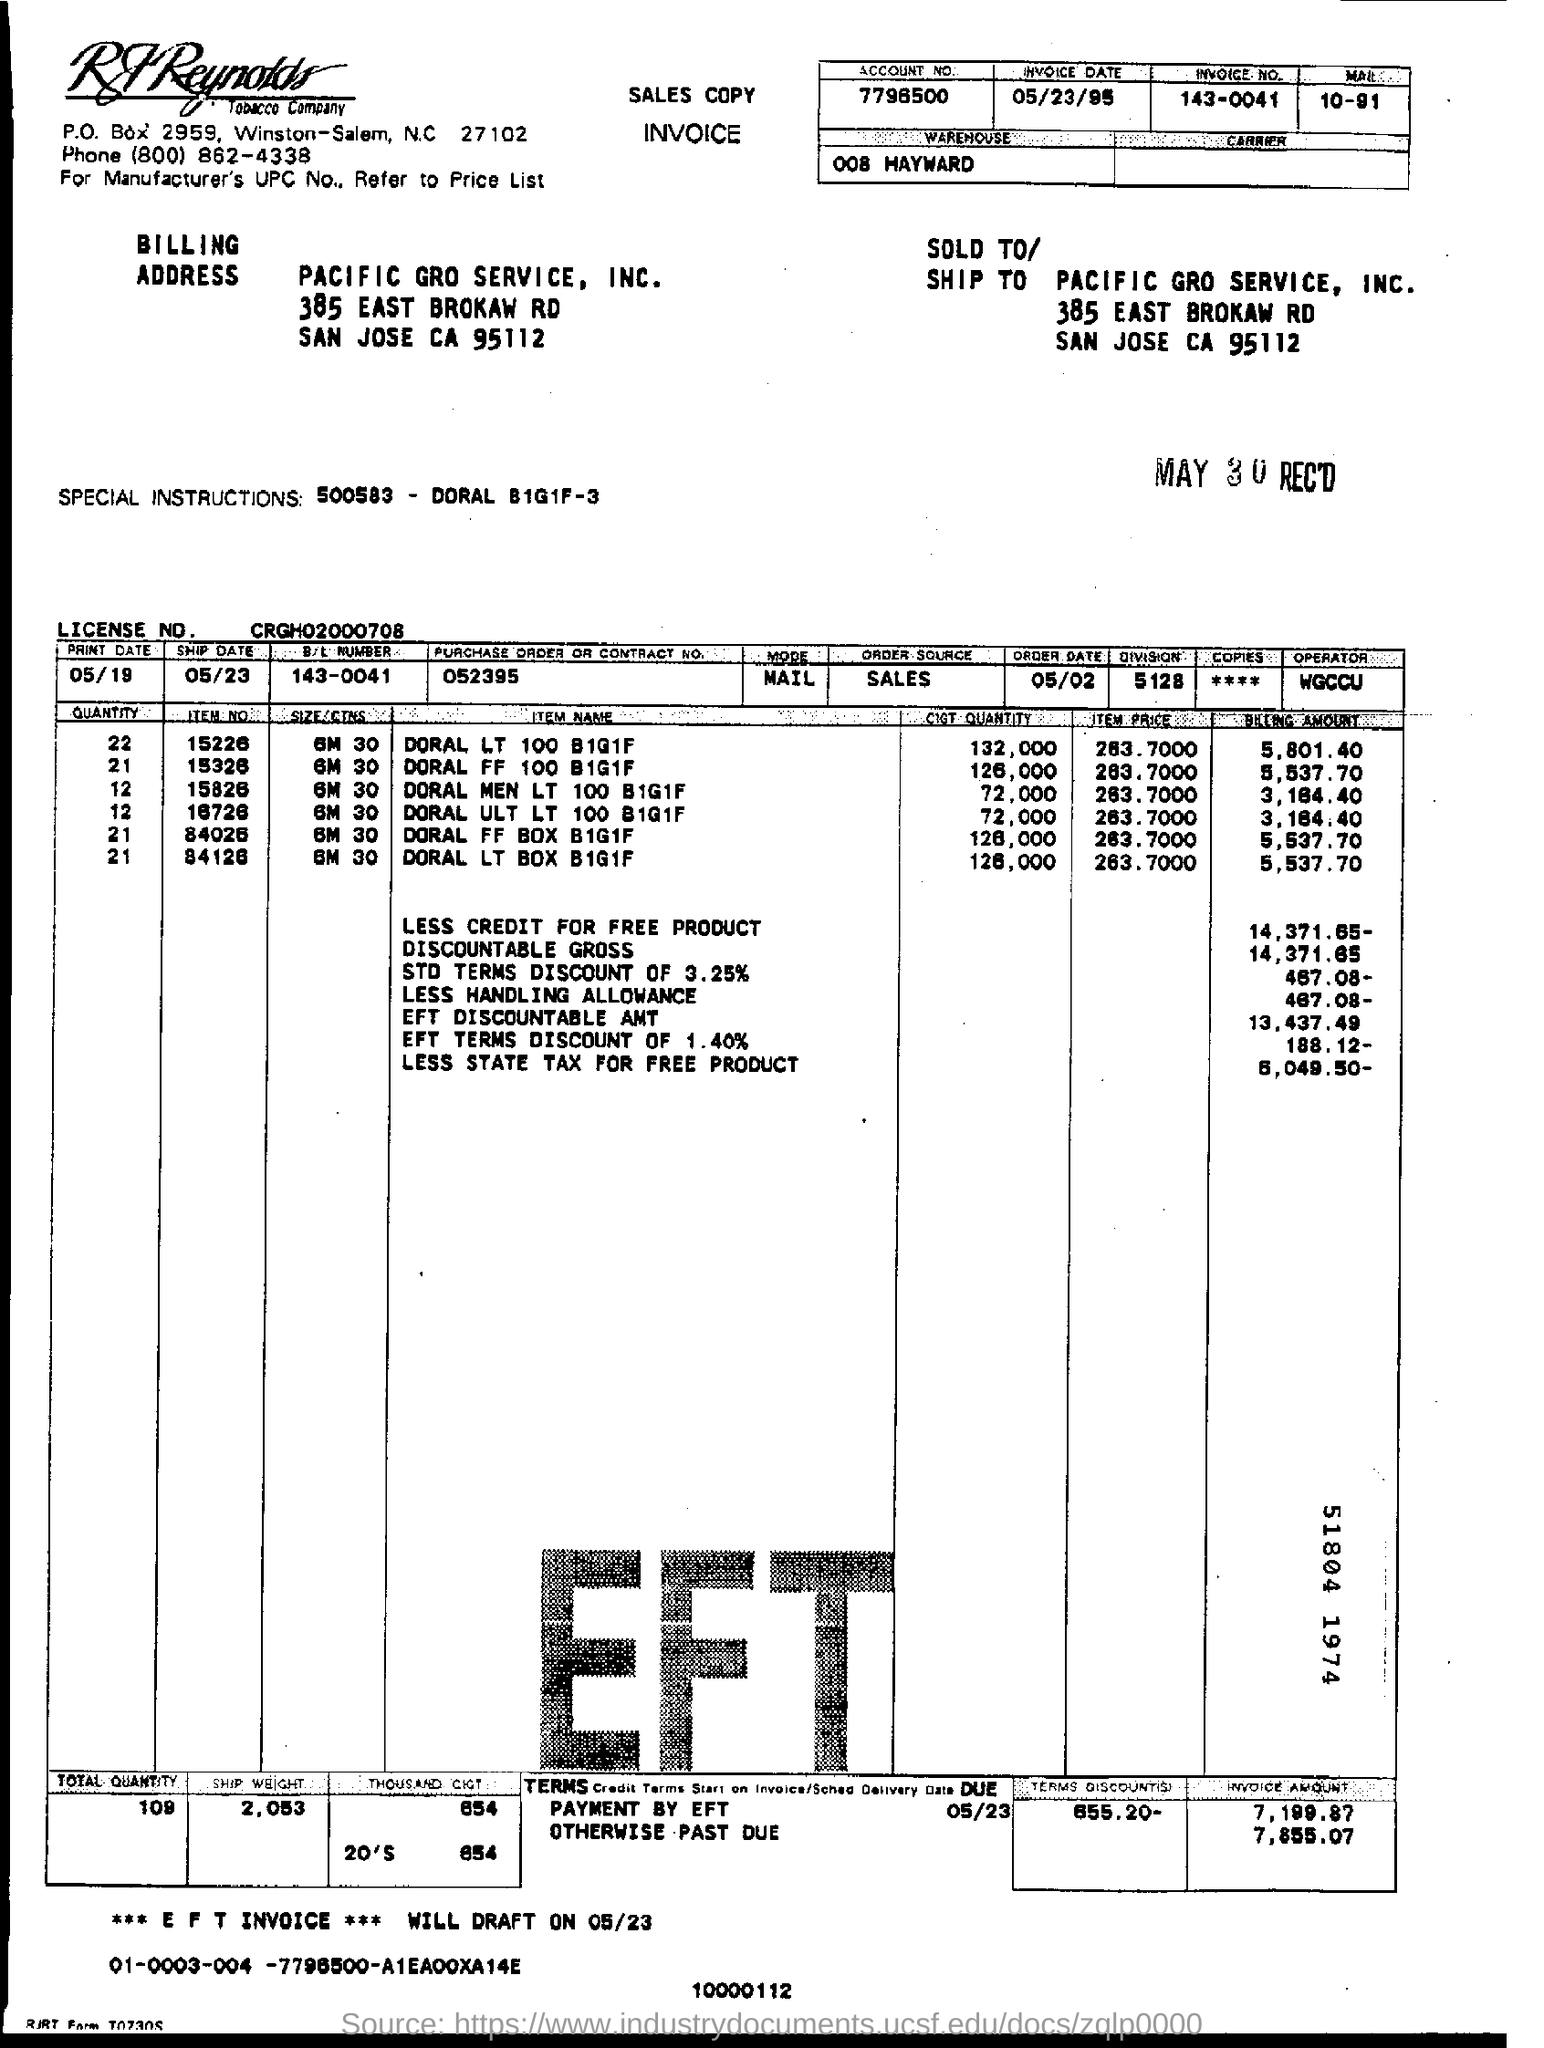Give some essential details in this illustration. The largest quantity of Item 100 purchased by DORAL LT was one box containing one unit of Item 100 at a discounted price of one unit for free. What is the Contract Number or PURCHASE ORDER? 052395... There are 655.20 discount terms. The account number provided on the invoice is 7796500... What is the license number?" CRGH02000708... 